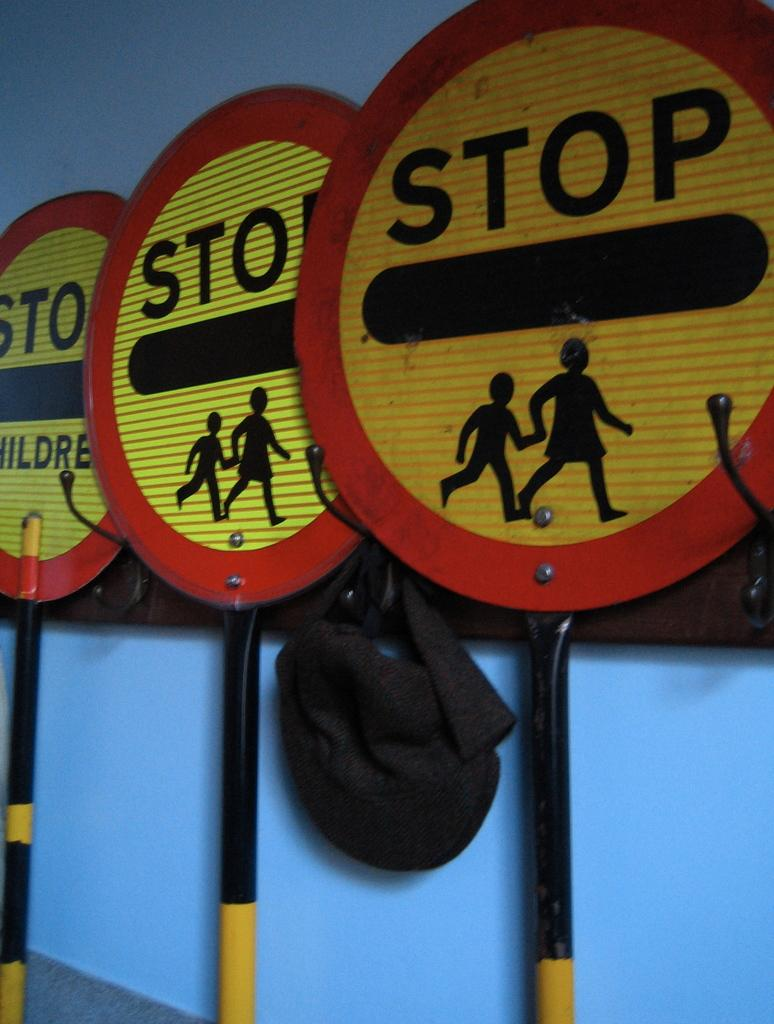<image>
Offer a succinct explanation of the picture presented. Three signs showing a woman holding her child and says STOP on it. 